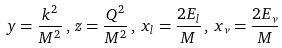<formula> <loc_0><loc_0><loc_500><loc_500>y = \frac { k ^ { 2 } } { M ^ { 2 } } \, , \, z = \frac { Q ^ { 2 } } { M ^ { 2 } } \, , \, x _ { l } = \frac { 2 E _ { l } } { M } \, , \, x _ { \nu } = \frac { 2 E _ { \nu } } { M }</formula> 